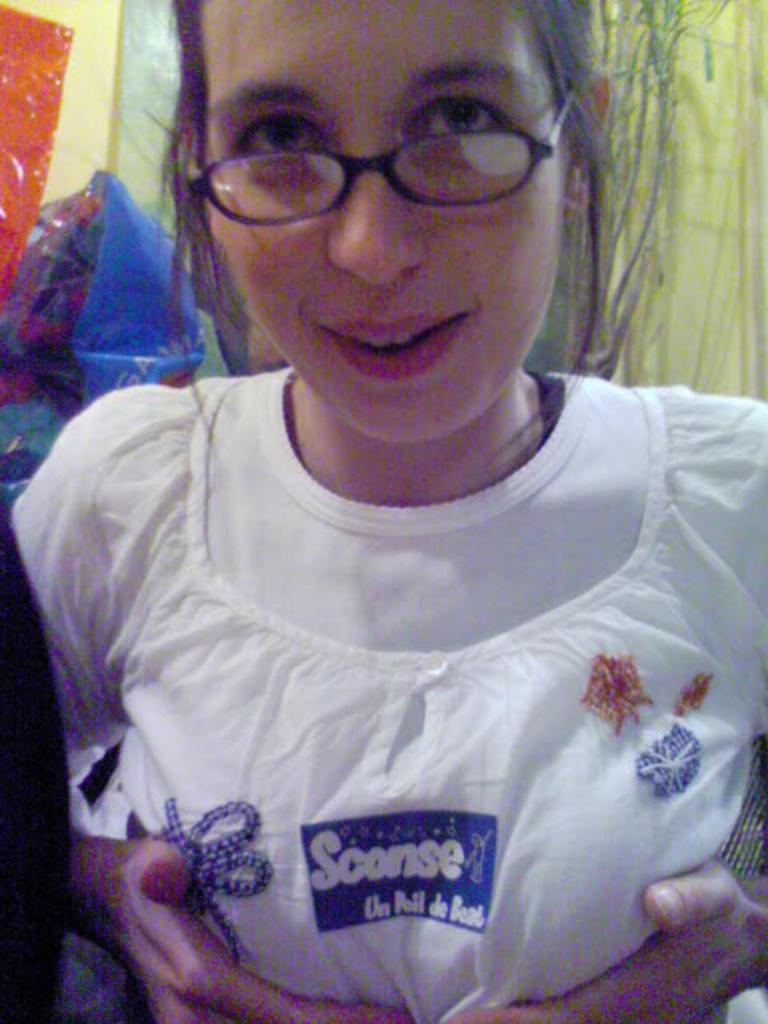How would you summarize this image in a sentence or two? In the front of the image I can see a woman wore spectacles. In the background of the image there are objects. 